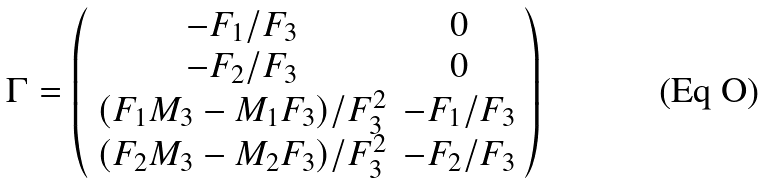<formula> <loc_0><loc_0><loc_500><loc_500>\Gamma = \left ( \begin{array} { c c } - F _ { 1 } / F _ { 3 } & 0 \\ - F _ { 2 } / F _ { 3 } & 0 \\ ( F _ { 1 } M _ { 3 } - M _ { 1 } F _ { 3 } ) / F _ { 3 } ^ { 2 } & - F _ { 1 } / F _ { 3 } \\ ( F _ { 2 } M _ { 3 } - M _ { 2 } F _ { 3 } ) / F _ { 3 } ^ { 2 } & - F _ { 2 } / F _ { 3 } \end{array} \right )</formula> 